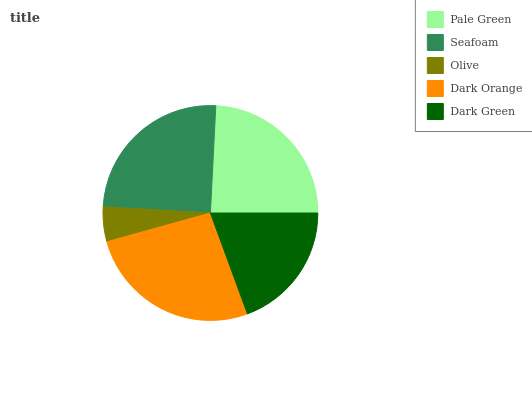Is Olive the minimum?
Answer yes or no. Yes. Is Dark Orange the maximum?
Answer yes or no. Yes. Is Seafoam the minimum?
Answer yes or no. No. Is Seafoam the maximum?
Answer yes or no. No. Is Seafoam greater than Pale Green?
Answer yes or no. Yes. Is Pale Green less than Seafoam?
Answer yes or no. Yes. Is Pale Green greater than Seafoam?
Answer yes or no. No. Is Seafoam less than Pale Green?
Answer yes or no. No. Is Pale Green the high median?
Answer yes or no. Yes. Is Pale Green the low median?
Answer yes or no. Yes. Is Dark Orange the high median?
Answer yes or no. No. Is Dark Orange the low median?
Answer yes or no. No. 